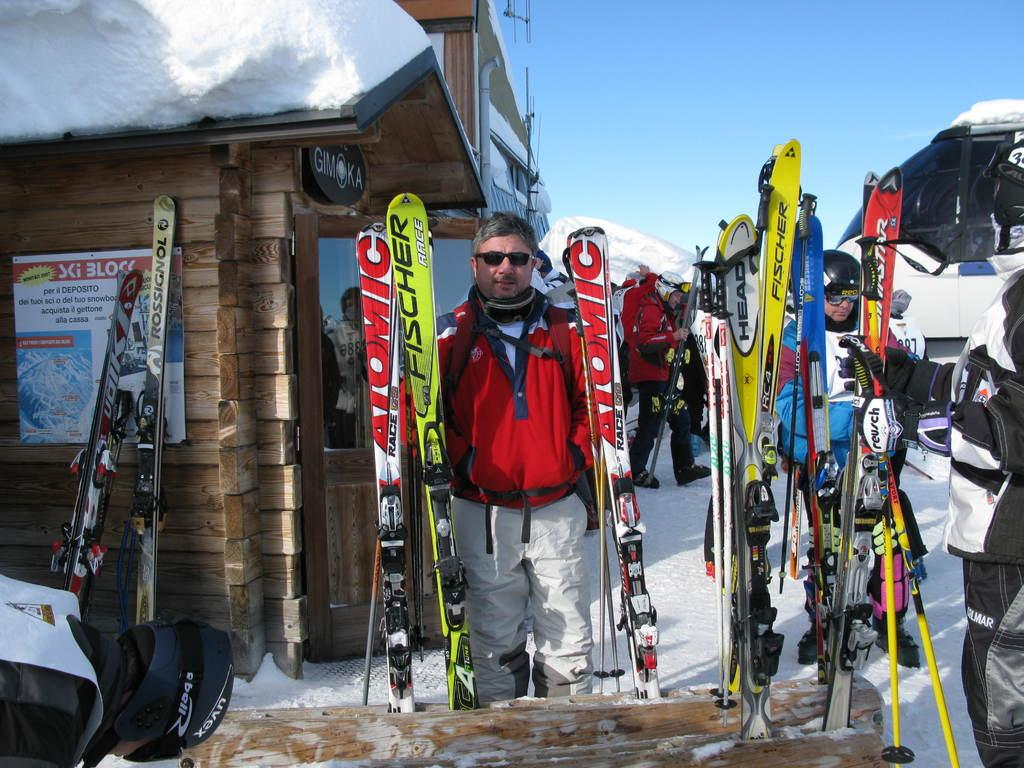How many people are visible in the image? There are many people standing in the image. What else can be seen in the image besides the people? There is a vehicle, snow, a house, and the sky in the image. Can you describe the vehicle in the image? The facts provided do not give specific details about the vehicle. What is the color of the sky in the image? The sky is blue in the image. Where is the cheese located in the image? There is no cheese present in the image. What type of sidewalk can be seen in the image? There is no sidewalk present in the image. 